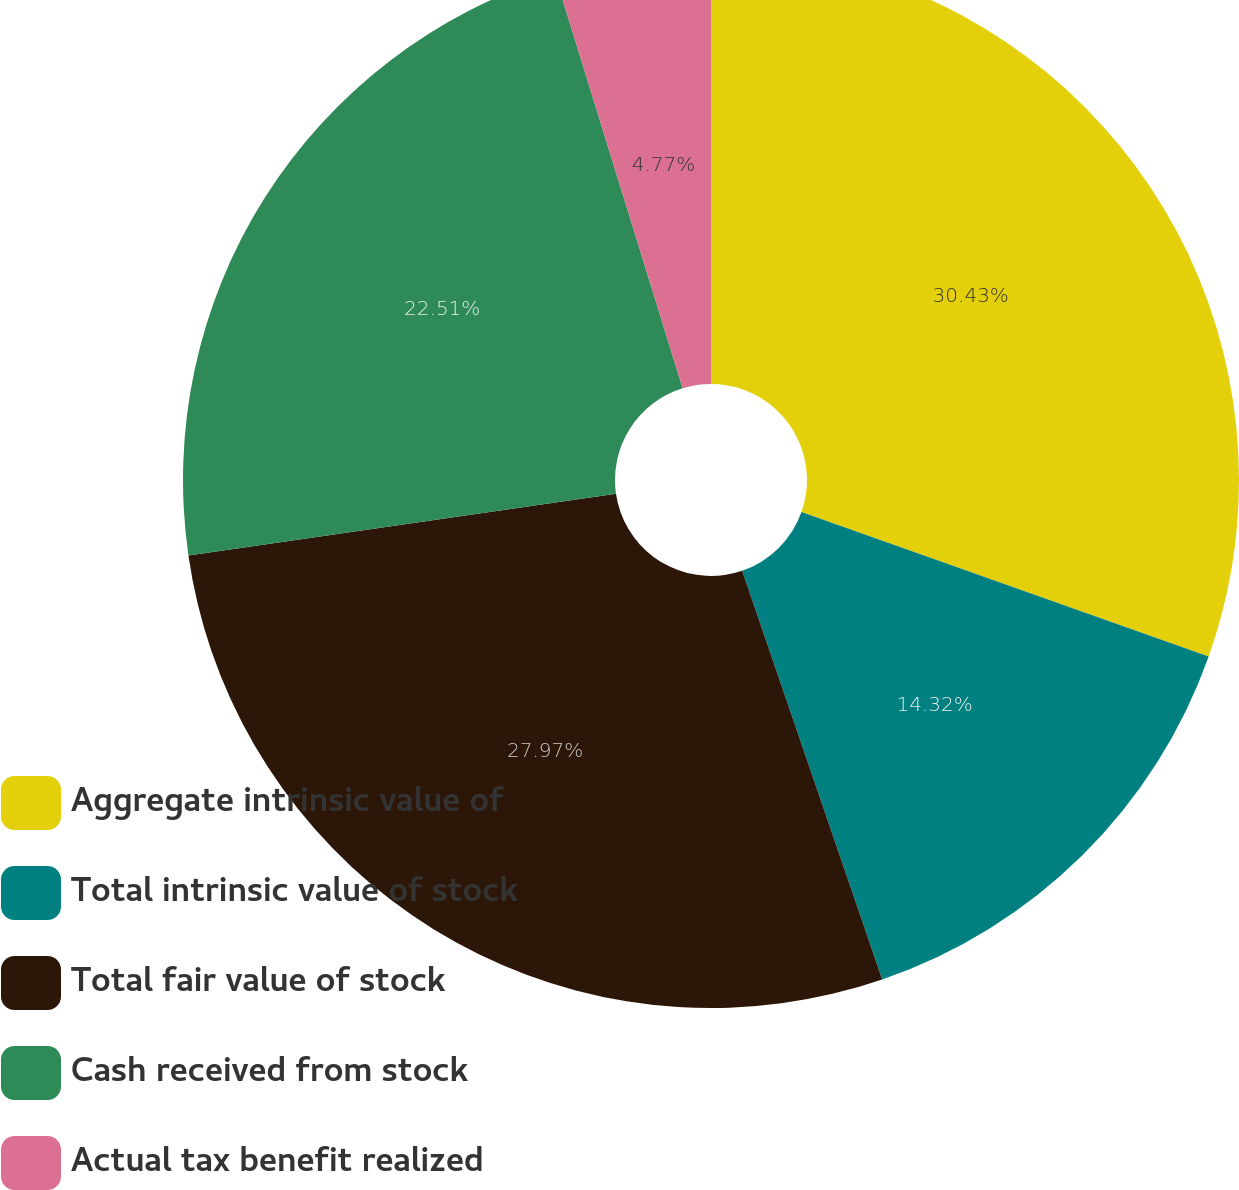Convert chart to OTSL. <chart><loc_0><loc_0><loc_500><loc_500><pie_chart><fcel>Aggregate intrinsic value of<fcel>Total intrinsic value of stock<fcel>Total fair value of stock<fcel>Cash received from stock<fcel>Actual tax benefit realized<nl><fcel>30.42%<fcel>14.32%<fcel>27.97%<fcel>22.51%<fcel>4.77%<nl></chart> 